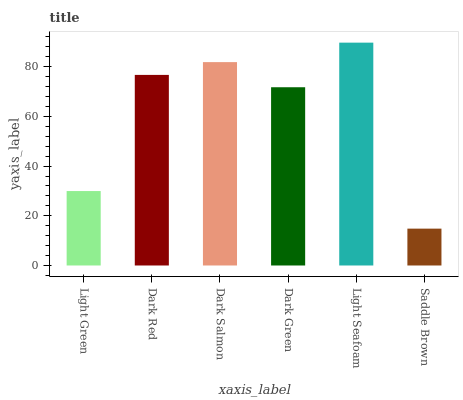Is Saddle Brown the minimum?
Answer yes or no. Yes. Is Light Seafoam the maximum?
Answer yes or no. Yes. Is Dark Red the minimum?
Answer yes or no. No. Is Dark Red the maximum?
Answer yes or no. No. Is Dark Red greater than Light Green?
Answer yes or no. Yes. Is Light Green less than Dark Red?
Answer yes or no. Yes. Is Light Green greater than Dark Red?
Answer yes or no. No. Is Dark Red less than Light Green?
Answer yes or no. No. Is Dark Red the high median?
Answer yes or no. Yes. Is Dark Green the low median?
Answer yes or no. Yes. Is Light Seafoam the high median?
Answer yes or no. No. Is Dark Red the low median?
Answer yes or no. No. 